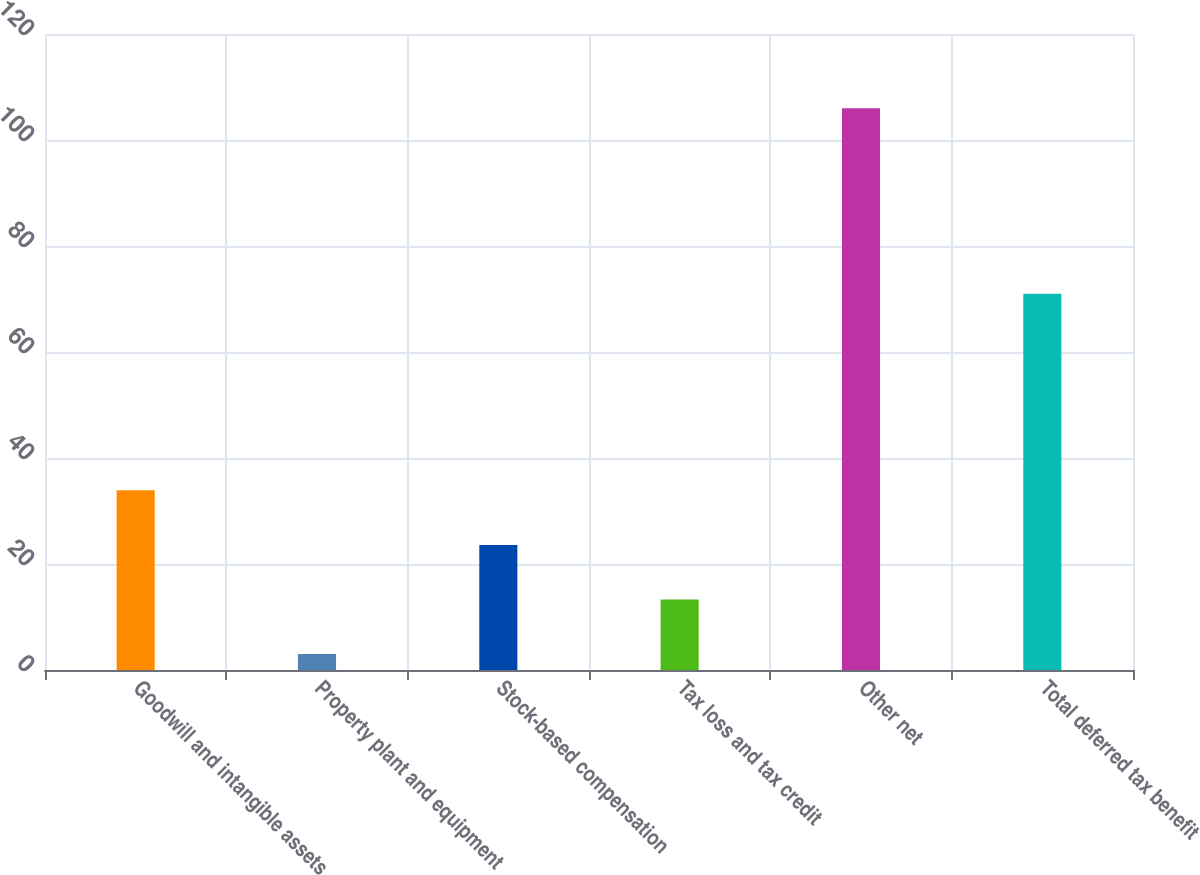Convert chart. <chart><loc_0><loc_0><loc_500><loc_500><bar_chart><fcel>Goodwill and intangible assets<fcel>Property plant and equipment<fcel>Stock-based compensation<fcel>Tax loss and tax credit<fcel>Other net<fcel>Total deferred tax benefit<nl><fcel>33.9<fcel>3<fcel>23.6<fcel>13.3<fcel>106<fcel>71<nl></chart> 